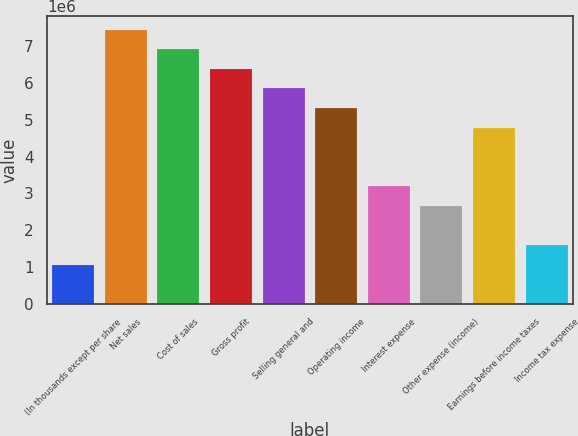Convert chart to OTSL. <chart><loc_0><loc_0><loc_500><loc_500><bar_chart><fcel>(In thousands except per share<fcel>Net sales<fcel>Cost of sales<fcel>Gross profit<fcel>Selling general and<fcel>Operating income<fcel>Interest expense<fcel>Other expense (income)<fcel>Earnings before income taxes<fcel>Income tax expense<nl><fcel>1.06382e+06<fcel>7.4467e+06<fcel>6.91479e+06<fcel>6.38289e+06<fcel>5.85098e+06<fcel>5.31907e+06<fcel>3.19144e+06<fcel>2.65954e+06<fcel>4.78717e+06<fcel>1.59572e+06<nl></chart> 